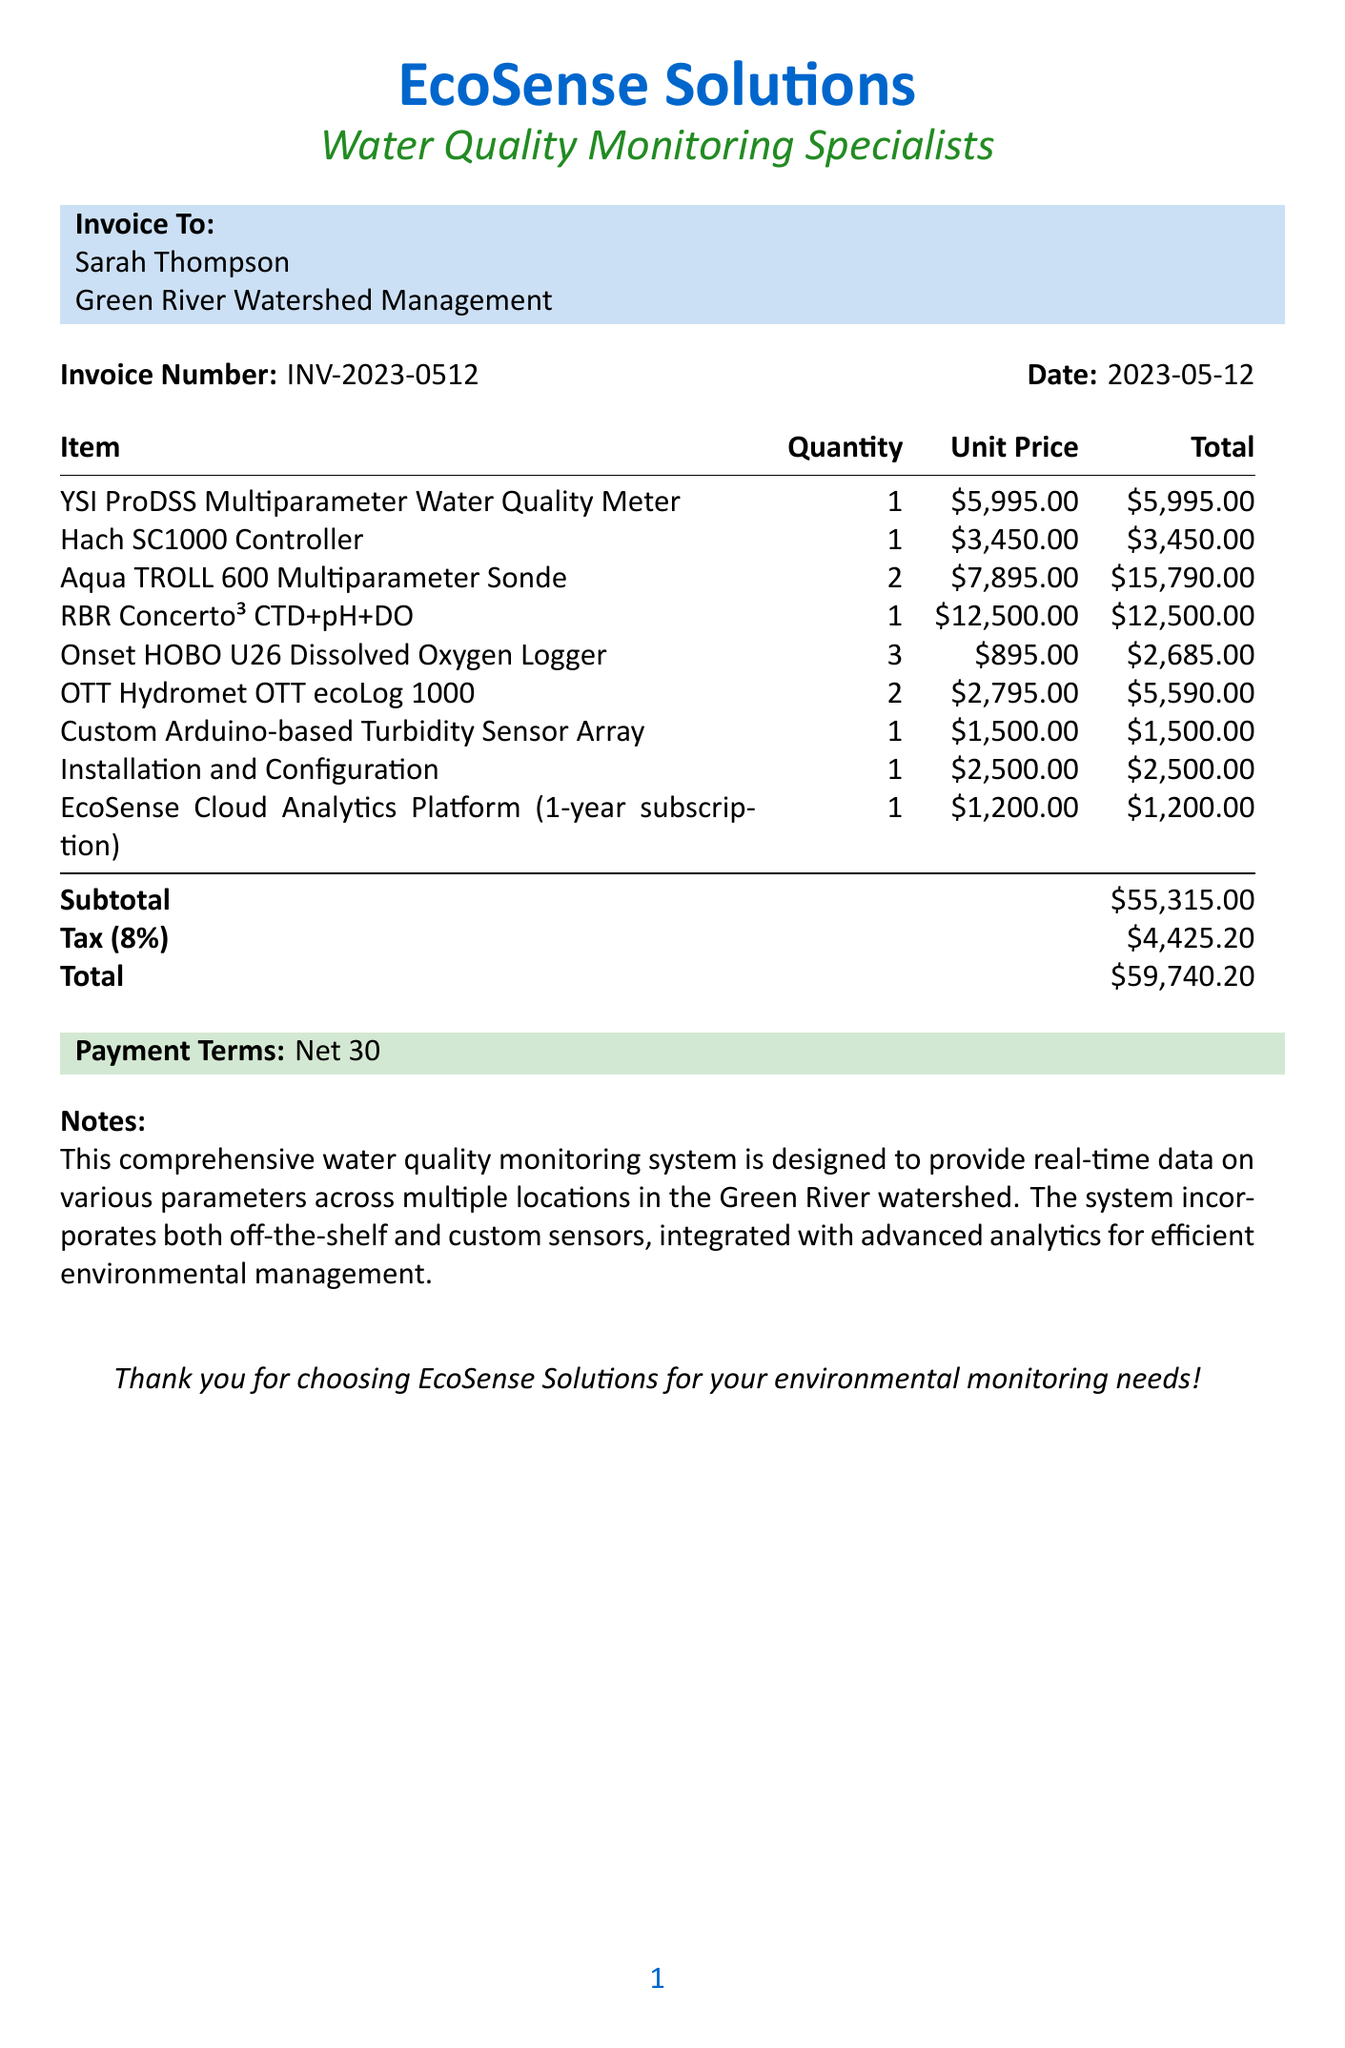What is the invoice number? The invoice number is listed clearly in the document for reference.
Answer: INV-2023-0512 Who is the client? The client’s name is mentioned for billing and contact purposes.
Answer: Sarah Thompson What is the total amount due? The total amount due is a critical part of the invoice.
Answer: $59,740.20 What is the tax rate applied? The tax rate must be outlined for clarity on tax calculations.
Answer: 8% How many Aqua TROLL 600 Multiparameter Sondes were ordered? This asks for the quantity of a specific item listed.
Answer: 2 What type of monitoring does the EcoSense Cloud Analytics Platform enable? This information describes the key feature of one of the items in the invoice.
Answer: data management and analysis What is included in the Installation and Configuration item? The item description specifies the nature of the service provided.
Answer: On-site installation, calibration, and integration What is the payment term? The payment term indicates the due period for the payment as per the invoice.
Answer: Net 30 What does the custom sensor array pertain to? This clarifies the function of the custom equipment listed in the invoice.
Answer: high-resolution turbidity mapping 